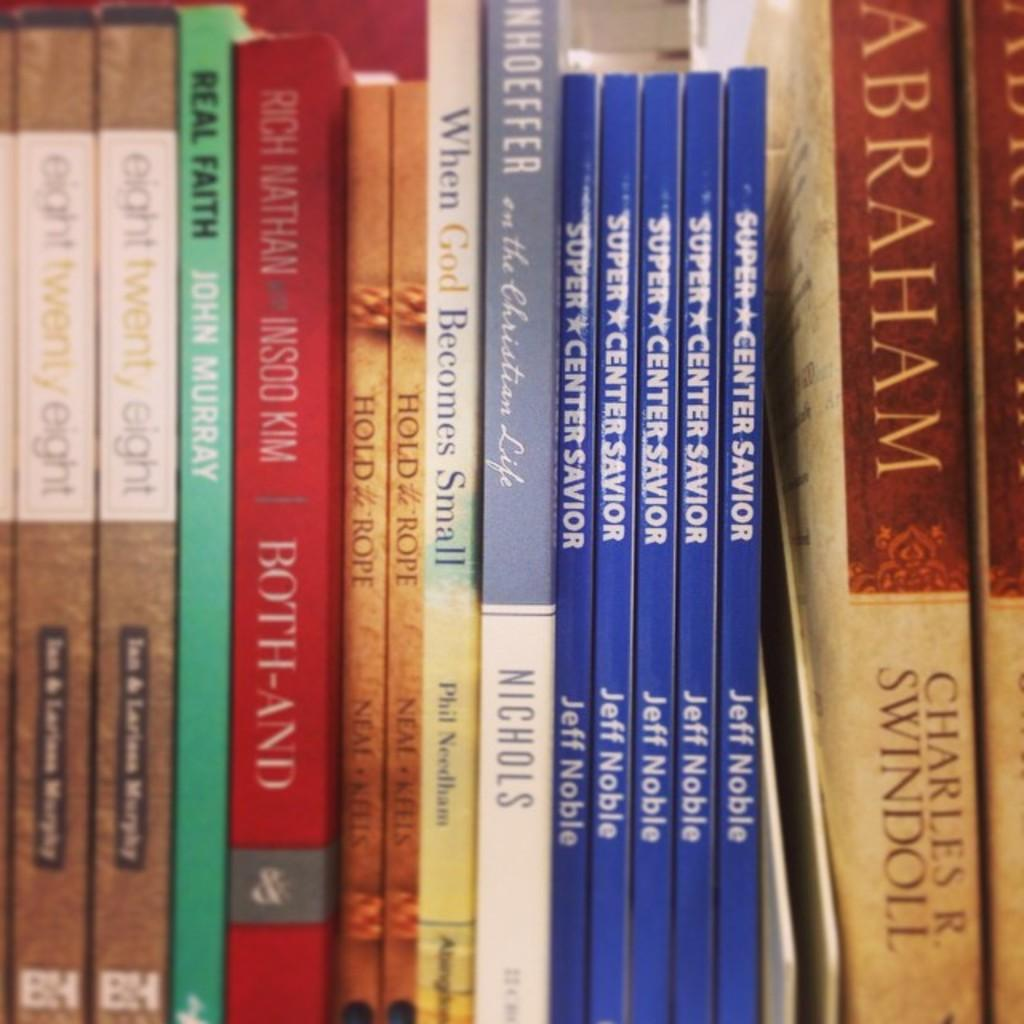What is arranged in the image? There are books arranged in the image. What is on the books? The books have posters on them. What can be found on the posters? The posters contain text. Are there any other elements on the posters besides text? Yes, the posters have other designs. What type of sponge is used to clean the company's logo on the posters? There is no sponge or company logo present in the image. What question is being asked on the posters? There is no question visible on the posters in the image. 